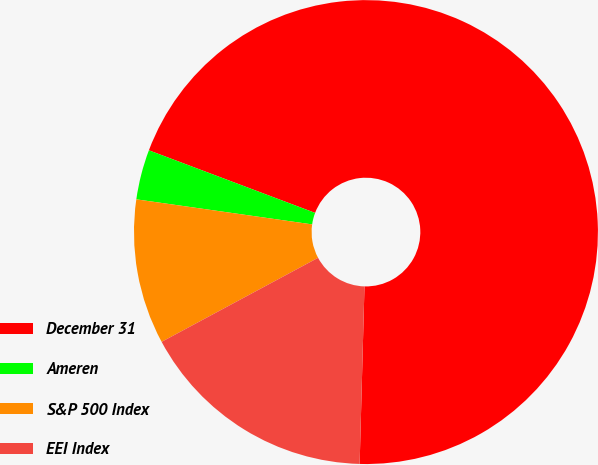Convert chart. <chart><loc_0><loc_0><loc_500><loc_500><pie_chart><fcel>December 31<fcel>Ameren<fcel>S&P 500 Index<fcel>EEI Index<nl><fcel>69.7%<fcel>3.48%<fcel>10.1%<fcel>16.72%<nl></chart> 